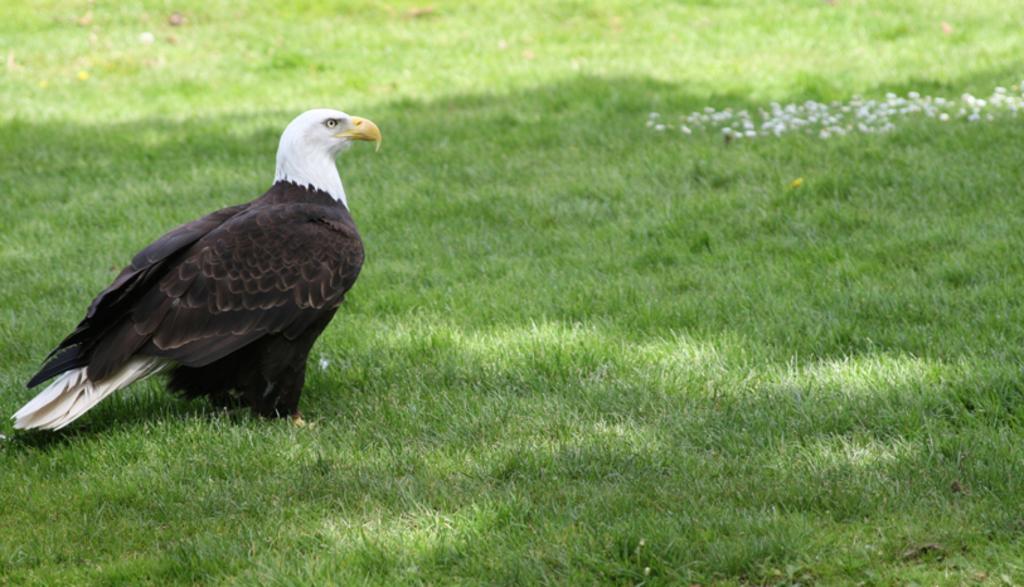Can you describe this image briefly? In this image I can see the grass on the ground. On the left side, I can see a bird facing towards the right side. 